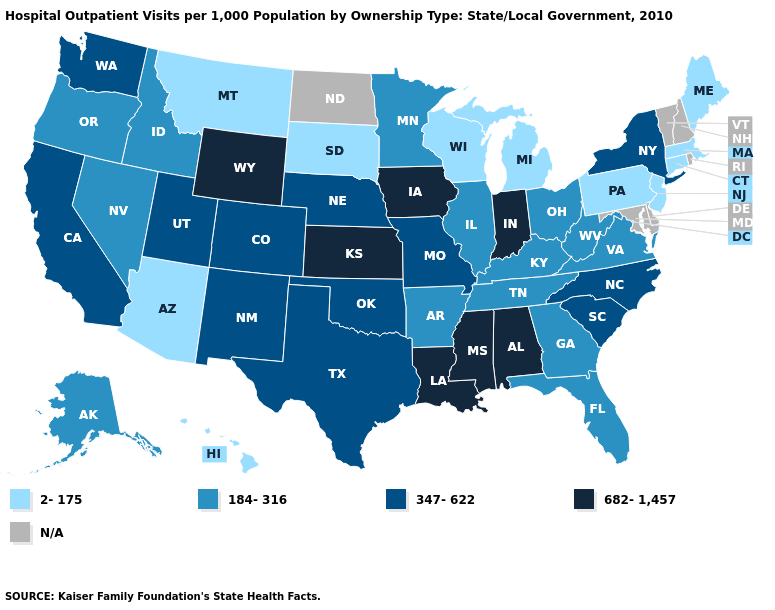What is the value of Tennessee?
Write a very short answer. 184-316. Does Arizona have the lowest value in the West?
Short answer required. Yes. Among the states that border Texas , which have the lowest value?
Write a very short answer. Arkansas. What is the value of New Mexico?
Write a very short answer. 347-622. Which states have the highest value in the USA?
Write a very short answer. Alabama, Indiana, Iowa, Kansas, Louisiana, Mississippi, Wyoming. Among the states that border Tennessee , does Kentucky have the lowest value?
Answer briefly. Yes. Name the states that have a value in the range 184-316?
Answer briefly. Alaska, Arkansas, Florida, Georgia, Idaho, Illinois, Kentucky, Minnesota, Nevada, Ohio, Oregon, Tennessee, Virginia, West Virginia. Which states have the lowest value in the MidWest?
Quick response, please. Michigan, South Dakota, Wisconsin. Does Kansas have the highest value in the USA?
Answer briefly. Yes. What is the value of Kansas?
Be succinct. 682-1,457. Among the states that border Louisiana , does Mississippi have the highest value?
Be succinct. Yes. Among the states that border Texas , does Louisiana have the lowest value?
Keep it brief. No. Name the states that have a value in the range 347-622?
Write a very short answer. California, Colorado, Missouri, Nebraska, New Mexico, New York, North Carolina, Oklahoma, South Carolina, Texas, Utah, Washington. Name the states that have a value in the range 184-316?
Answer briefly. Alaska, Arkansas, Florida, Georgia, Idaho, Illinois, Kentucky, Minnesota, Nevada, Ohio, Oregon, Tennessee, Virginia, West Virginia. Is the legend a continuous bar?
Concise answer only. No. 